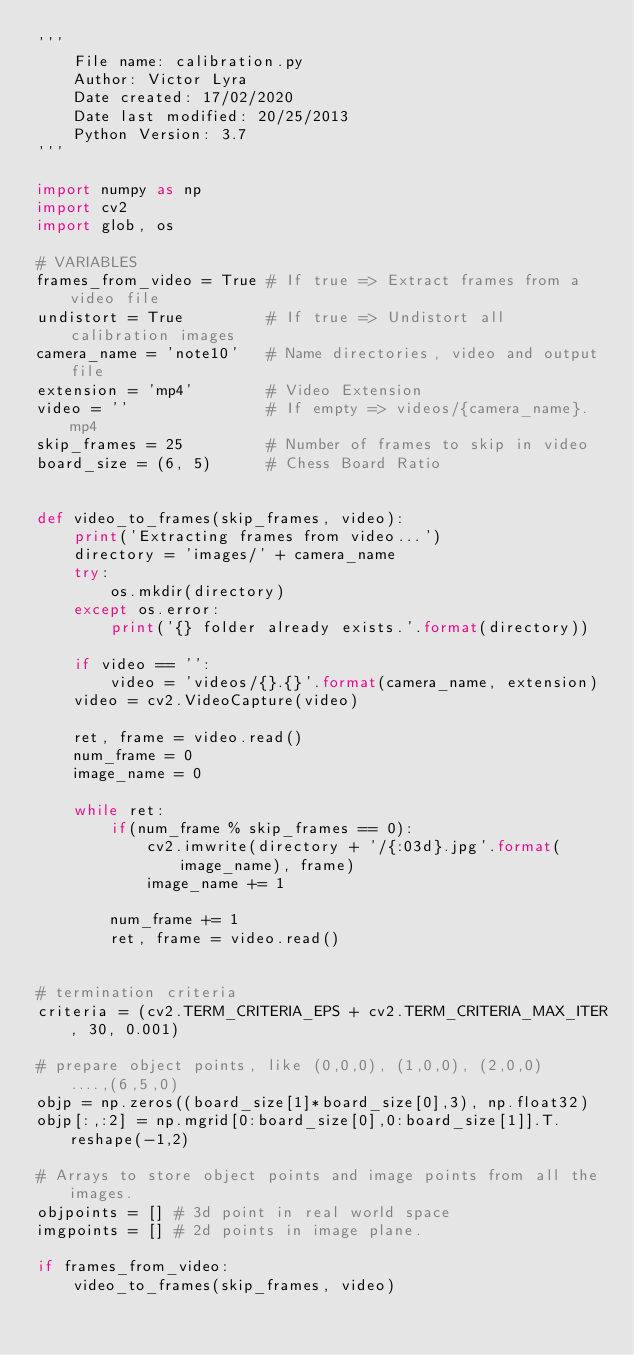<code> <loc_0><loc_0><loc_500><loc_500><_Python_>'''
    File name: calibration.py
    Author: Victor Lyra
    Date created: 17/02/2020
    Date last modified: 20/25/2013
    Python Version: 3.7
'''

import numpy as np
import cv2
import glob, os

# VARIABLES
frames_from_video = True # If true => Extract frames from a video file
undistort = True         # If true => Undistort all calibration images
camera_name = 'note10'   # Name directories, video and output file
extension = 'mp4'        # Video Extension
video = ''               # If empty => videos/{camera_name}.mp4
skip_frames = 25         # Number of frames to skip in video
board_size = (6, 5)      # Chess Board Ratio


def video_to_frames(skip_frames, video):
    print('Extracting frames from video...')
    directory = 'images/' + camera_name
    try:
        os.mkdir(directory)
    except os.error:
        print('{} folder already exists.'.format(directory))

    if video == '':
        video = 'videos/{}.{}'.format(camera_name, extension)
    video = cv2.VideoCapture(video)

    ret, frame = video.read()
    num_frame = 0
    image_name = 0

    while ret:
        if(num_frame % skip_frames == 0):
            cv2.imwrite(directory + '/{:03d}.jpg'.format(image_name), frame)
            image_name += 1

        num_frame += 1
        ret, frame = video.read()


# termination criteria
criteria = (cv2.TERM_CRITERIA_EPS + cv2.TERM_CRITERIA_MAX_ITER, 30, 0.001)

# prepare object points, like (0,0,0), (1,0,0), (2,0,0) ....,(6,5,0)
objp = np.zeros((board_size[1]*board_size[0],3), np.float32)
objp[:,:2] = np.mgrid[0:board_size[0],0:board_size[1]].T.reshape(-1,2)

# Arrays to store object points and image points from all the images.
objpoints = [] # 3d point in real world space
imgpoints = [] # 2d points in image plane.

if frames_from_video:
    video_to_frames(skip_frames, video)
</code> 